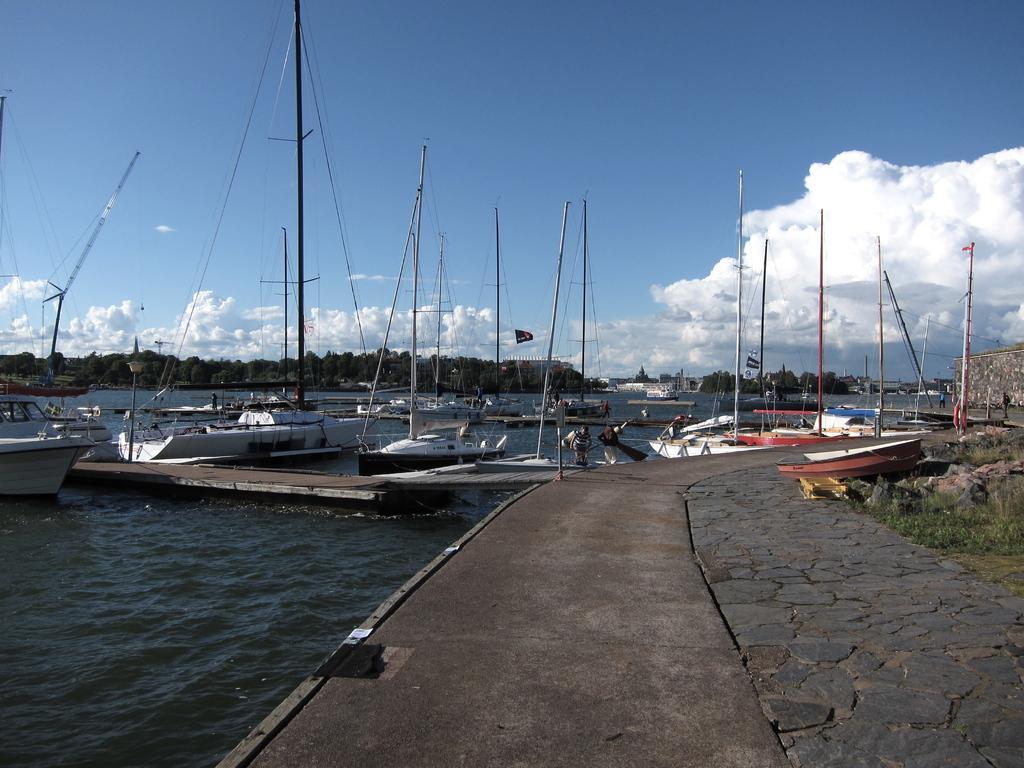Could you give a brief overview of what you see in this image? In the picture I can see a way and there are few boats on the water beside it and there are trees and some other objects in the background and the sky is a bit cloudy. 